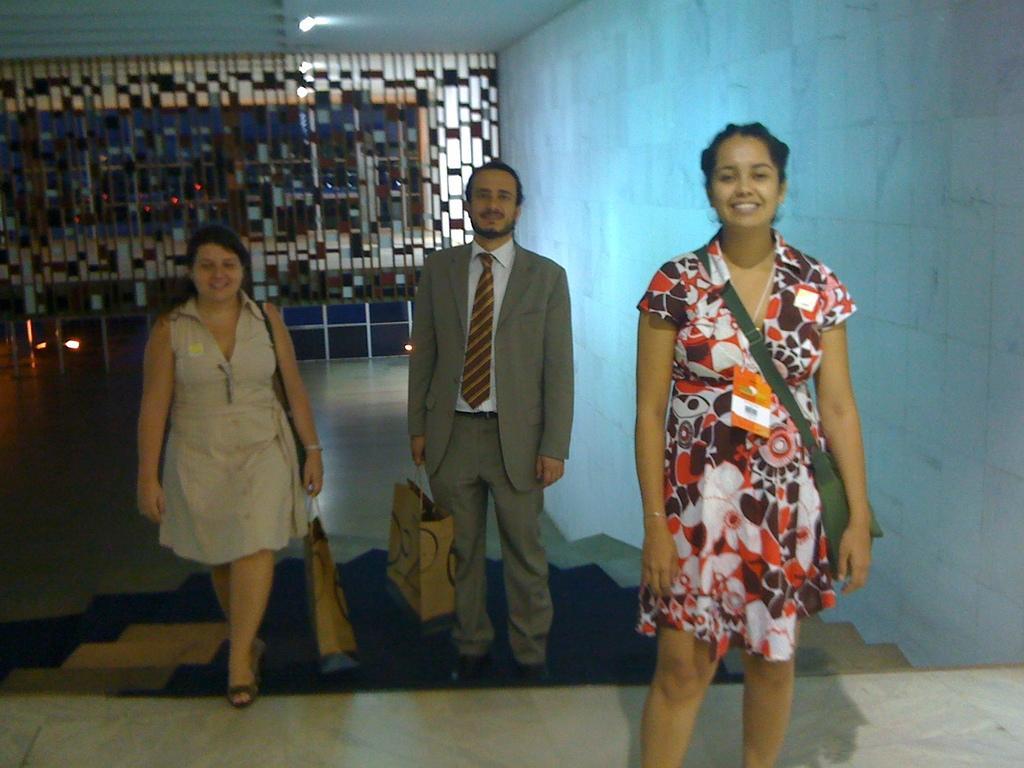Describe this image in one or two sentences. In this image we can see three persons wearing dress are standing on the staircase. One woman is carrying a bag, two persons are holding bags with their hands. In the background, we can see a fence, a group of lights and wall. 